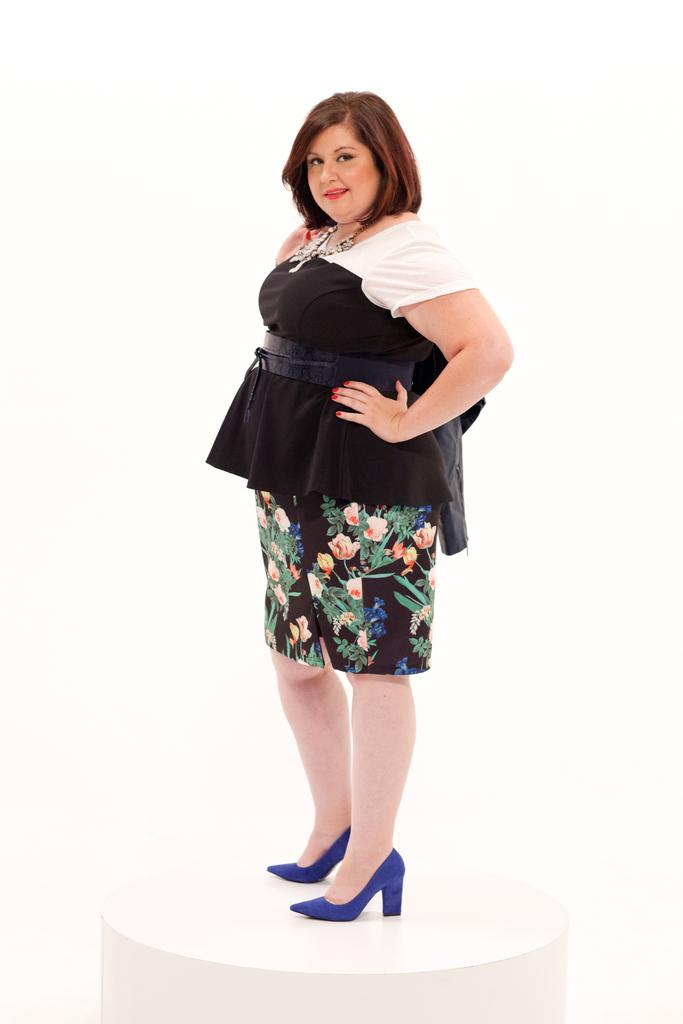Who is present in the image? There is a woman in the image. What is the woman doing in the image? The woman is standing on a white table. What color is the table the woman is standing on? The table is white. What can be seen in the background of the image? The background of the image is white. What type of stone is the woman using to balance on the table in the image? There is no stone present in the image, and the woman is not balancing on anything. 